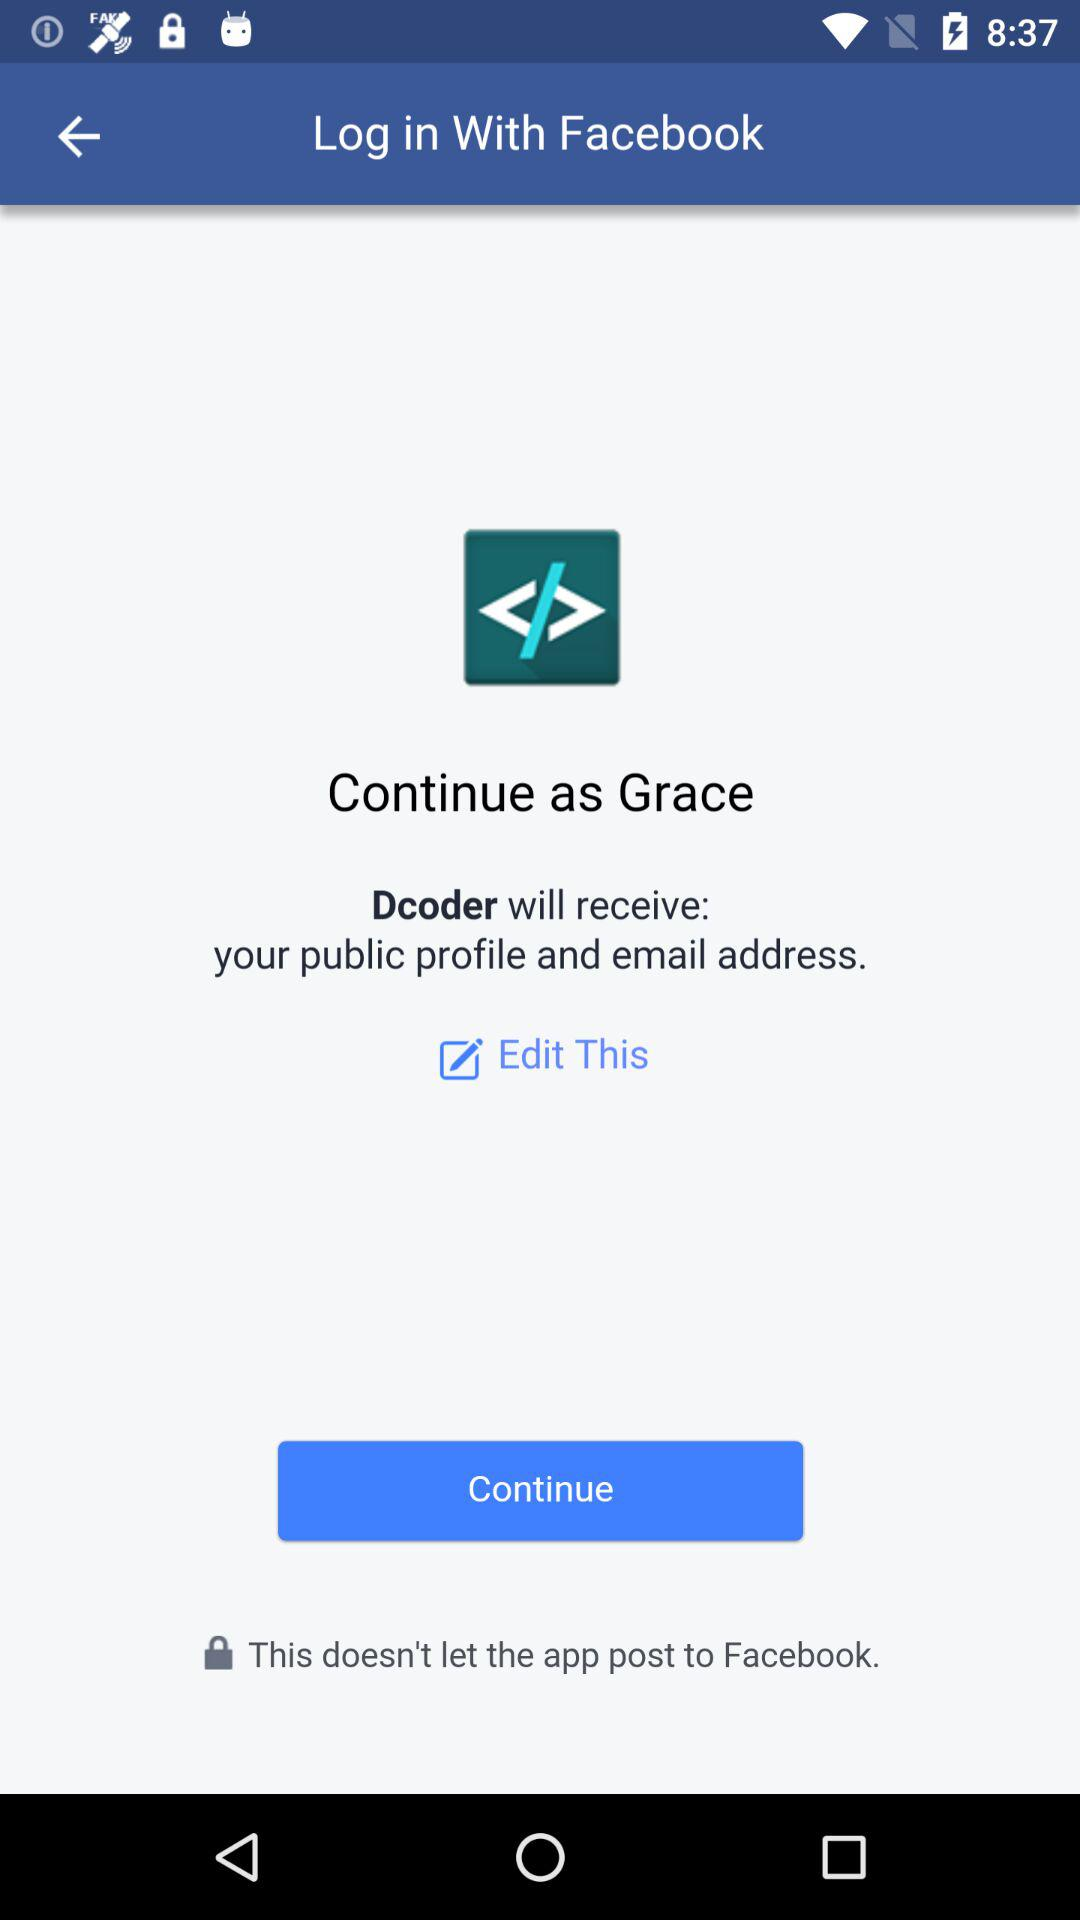What is the name of the user? The name of the user is Grace. 